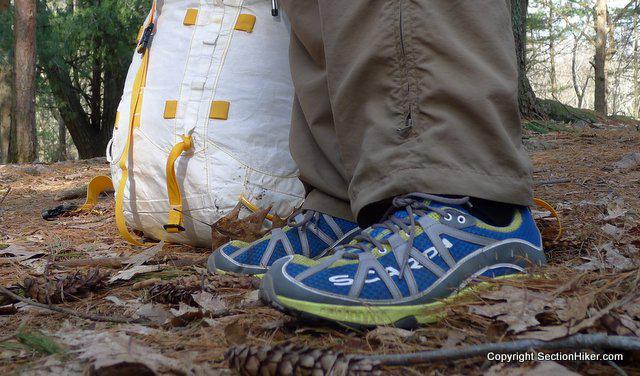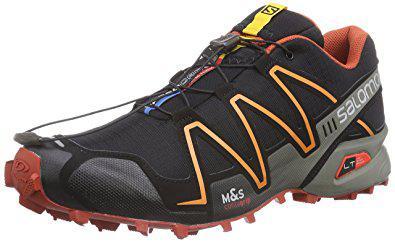The first image is the image on the left, the second image is the image on the right. Given the left and right images, does the statement "The shoes in the left image are facing opposite each other." hold true? Answer yes or no. No. 